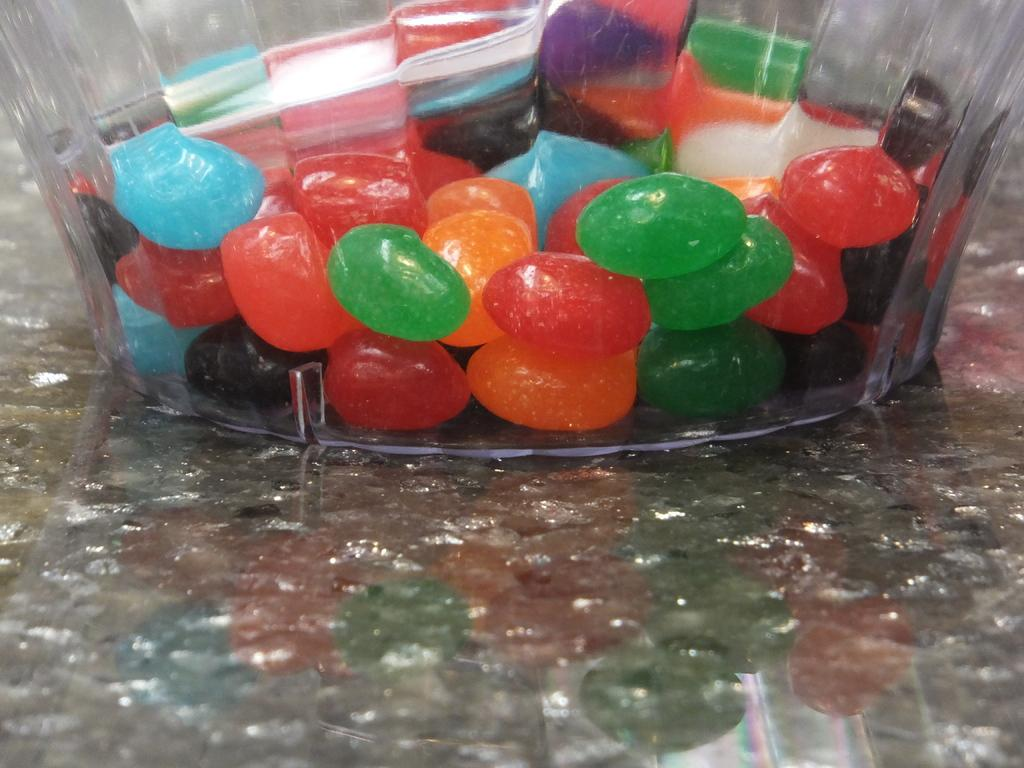What type of sweets can be seen in the image? There are candies in the image. How are the candies stored or displayed in the image? The candies are in a jar. What type of chair is visible in the image? There is no chair present in the image. What is the candies made of in the image? The provided facts do not mention the composition of the candies, so we cannot determine what they are made of. 